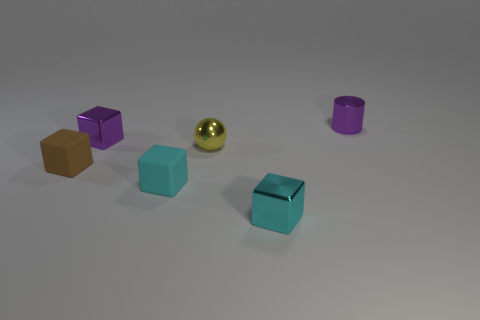Is the cylinder the same color as the ball?
Offer a very short reply. No. How many metal objects are either cyan objects or tiny yellow balls?
Provide a succinct answer. 2. There is a tiny metallic block that is in front of the cyan thing that is behind the small cyan shiny block; are there any small objects on the right side of it?
Ensure brevity in your answer.  Yes. There is a purple cube that is made of the same material as the tiny cylinder; what is its size?
Offer a terse response. Small. Are there any tiny cyan shiny things in front of the small cyan metal block?
Give a very brief answer. No. There is a matte object to the right of the small brown thing; is there a tiny shiny sphere in front of it?
Provide a succinct answer. No. Is the size of the block to the right of the yellow metal thing the same as the purple metal thing right of the tiny cyan rubber object?
Provide a succinct answer. Yes. What number of small things are cylinders or cyan things?
Provide a short and direct response. 3. There is a small purple object behind the purple metallic object in front of the tiny purple cylinder; what is it made of?
Provide a short and direct response. Metal. There is a tiny shiny object that is the same color as the shiny cylinder; what is its shape?
Ensure brevity in your answer.  Cube. 